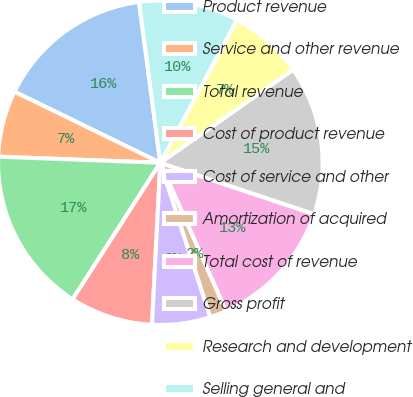Convert chart to OTSL. <chart><loc_0><loc_0><loc_500><loc_500><pie_chart><fcel>Product revenue<fcel>Service and other revenue<fcel>Total revenue<fcel>Cost of product revenue<fcel>Cost of service and other<fcel>Amortization of acquired<fcel>Total cost of revenue<fcel>Gross profit<fcel>Research and development<fcel>Selling general and<nl><fcel>15.69%<fcel>6.62%<fcel>16.51%<fcel>8.27%<fcel>5.8%<fcel>1.67%<fcel>13.22%<fcel>14.86%<fcel>7.44%<fcel>9.92%<nl></chart> 